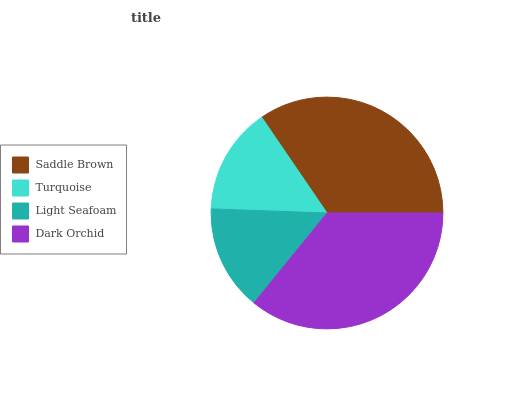Is Light Seafoam the minimum?
Answer yes or no. Yes. Is Dark Orchid the maximum?
Answer yes or no. Yes. Is Turquoise the minimum?
Answer yes or no. No. Is Turquoise the maximum?
Answer yes or no. No. Is Saddle Brown greater than Turquoise?
Answer yes or no. Yes. Is Turquoise less than Saddle Brown?
Answer yes or no. Yes. Is Turquoise greater than Saddle Brown?
Answer yes or no. No. Is Saddle Brown less than Turquoise?
Answer yes or no. No. Is Saddle Brown the high median?
Answer yes or no. Yes. Is Turquoise the low median?
Answer yes or no. Yes. Is Dark Orchid the high median?
Answer yes or no. No. Is Light Seafoam the low median?
Answer yes or no. No. 